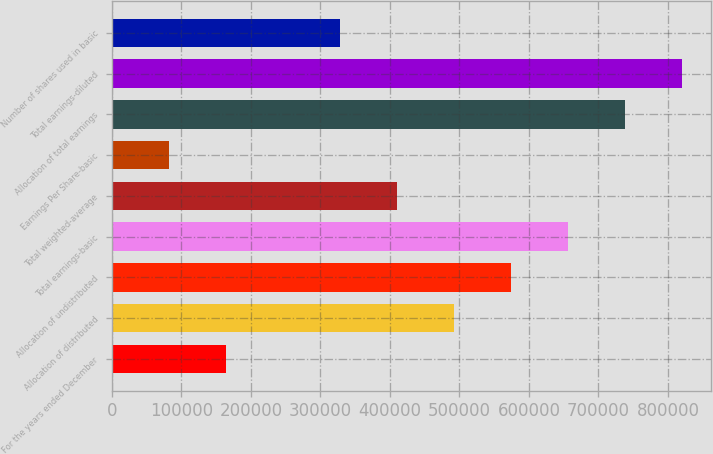Convert chart. <chart><loc_0><loc_0><loc_500><loc_500><bar_chart><fcel>For the years ended December<fcel>Allocation of distributed<fcel>Allocation of undistributed<fcel>Total earnings-basic<fcel>Total weighted-average<fcel>Earnings Per Share-basic<fcel>Allocation of total earnings<fcel>Total earnings-diluted<fcel>Number of shares used in basic<nl><fcel>164097<fcel>492283<fcel>574330<fcel>656377<fcel>410237<fcel>82050.2<fcel>738423<fcel>820470<fcel>328190<nl></chart> 